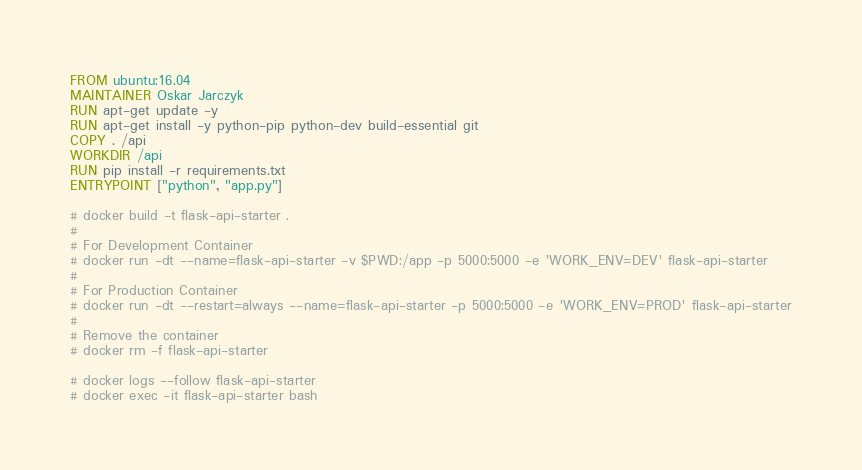Convert code to text. <code><loc_0><loc_0><loc_500><loc_500><_Dockerfile_>FROM ubuntu:16.04
MAINTAINER Oskar Jarczyk
RUN apt-get update -y
RUN apt-get install -y python-pip python-dev build-essential git
COPY . /api
WORKDIR /api
RUN pip install -r requirements.txt
ENTRYPOINT ["python", "app.py"]

# docker build -t flask-api-starter .
# 
# For Development Container
# docker run -dt --name=flask-api-starter -v $PWD:/app -p 5000:5000 -e 'WORK_ENV=DEV' flask-api-starter
# 
# For Production Container
# docker run -dt --restart=always --name=flask-api-starter -p 5000:5000 -e 'WORK_ENV=PROD' flask-api-starter
# 
# Remove the container
# docker rm -f flask-api-starter

# docker logs --follow flask-api-starter
# docker exec -it flask-api-starter bash
</code> 